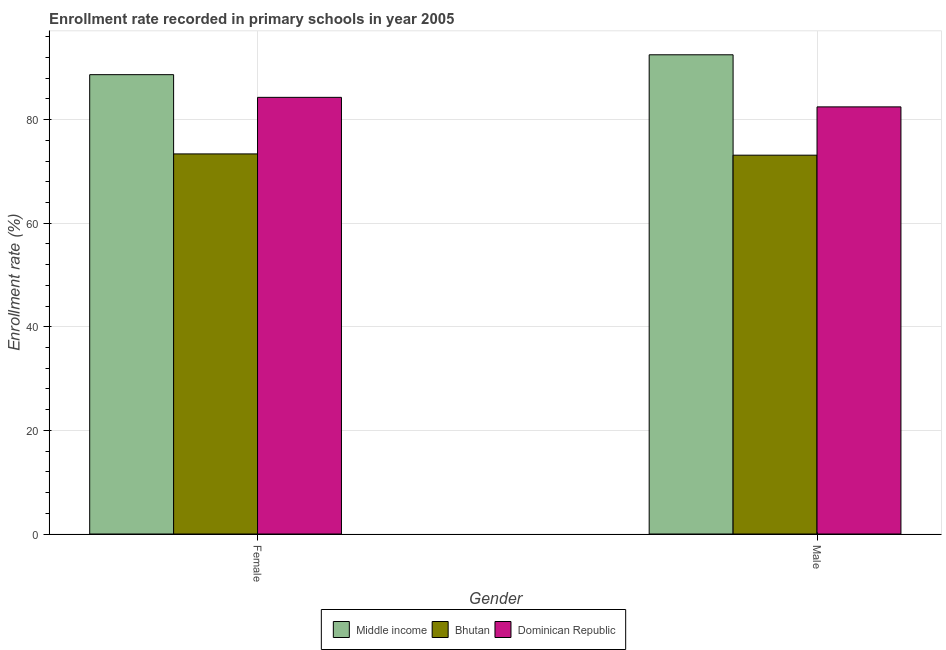How many groups of bars are there?
Your answer should be very brief. 2. Are the number of bars on each tick of the X-axis equal?
Your answer should be compact. Yes. How many bars are there on the 2nd tick from the left?
Your answer should be very brief. 3. What is the enrollment rate of male students in Middle income?
Offer a very short reply. 92.51. Across all countries, what is the maximum enrollment rate of male students?
Make the answer very short. 92.51. Across all countries, what is the minimum enrollment rate of female students?
Make the answer very short. 73.38. In which country was the enrollment rate of male students minimum?
Offer a very short reply. Bhutan. What is the total enrollment rate of female students in the graph?
Your answer should be compact. 246.35. What is the difference between the enrollment rate of male students in Middle income and that in Bhutan?
Ensure brevity in your answer.  19.38. What is the difference between the enrollment rate of male students in Bhutan and the enrollment rate of female students in Dominican Republic?
Offer a terse response. -11.16. What is the average enrollment rate of female students per country?
Provide a succinct answer. 82.12. What is the difference between the enrollment rate of female students and enrollment rate of male students in Dominican Republic?
Provide a succinct answer. 1.84. In how many countries, is the enrollment rate of female students greater than 24 %?
Your answer should be very brief. 3. What is the ratio of the enrollment rate of female students in Middle income to that in Dominican Republic?
Keep it short and to the point. 1.05. Is the enrollment rate of female students in Middle income less than that in Dominican Republic?
Ensure brevity in your answer.  No. In how many countries, is the enrollment rate of male students greater than the average enrollment rate of male students taken over all countries?
Your answer should be compact. 1. What does the 2nd bar from the left in Male represents?
Offer a very short reply. Bhutan. How many countries are there in the graph?
Your answer should be very brief. 3. What is the difference between two consecutive major ticks on the Y-axis?
Your answer should be very brief. 20. Are the values on the major ticks of Y-axis written in scientific E-notation?
Ensure brevity in your answer.  No. Does the graph contain any zero values?
Provide a succinct answer. No. Does the graph contain grids?
Keep it short and to the point. Yes. What is the title of the graph?
Keep it short and to the point. Enrollment rate recorded in primary schools in year 2005. What is the label or title of the X-axis?
Make the answer very short. Gender. What is the label or title of the Y-axis?
Make the answer very short. Enrollment rate (%). What is the Enrollment rate (%) of Middle income in Female?
Make the answer very short. 88.68. What is the Enrollment rate (%) in Bhutan in Female?
Your answer should be very brief. 73.38. What is the Enrollment rate (%) in Dominican Republic in Female?
Keep it short and to the point. 84.3. What is the Enrollment rate (%) in Middle income in Male?
Your answer should be very brief. 92.51. What is the Enrollment rate (%) in Bhutan in Male?
Your response must be concise. 73.13. What is the Enrollment rate (%) of Dominican Republic in Male?
Your answer should be compact. 82.46. Across all Gender, what is the maximum Enrollment rate (%) in Middle income?
Your response must be concise. 92.51. Across all Gender, what is the maximum Enrollment rate (%) of Bhutan?
Your answer should be very brief. 73.38. Across all Gender, what is the maximum Enrollment rate (%) in Dominican Republic?
Provide a succinct answer. 84.3. Across all Gender, what is the minimum Enrollment rate (%) of Middle income?
Offer a terse response. 88.68. Across all Gender, what is the minimum Enrollment rate (%) in Bhutan?
Your answer should be very brief. 73.13. Across all Gender, what is the minimum Enrollment rate (%) in Dominican Republic?
Your response must be concise. 82.46. What is the total Enrollment rate (%) of Middle income in the graph?
Your answer should be very brief. 181.19. What is the total Enrollment rate (%) in Bhutan in the graph?
Your answer should be compact. 146.51. What is the total Enrollment rate (%) of Dominican Republic in the graph?
Your response must be concise. 166.75. What is the difference between the Enrollment rate (%) of Middle income in Female and that in Male?
Offer a terse response. -3.84. What is the difference between the Enrollment rate (%) of Bhutan in Female and that in Male?
Make the answer very short. 0.24. What is the difference between the Enrollment rate (%) of Dominican Republic in Female and that in Male?
Make the answer very short. 1.84. What is the difference between the Enrollment rate (%) of Middle income in Female and the Enrollment rate (%) of Bhutan in Male?
Provide a short and direct response. 15.54. What is the difference between the Enrollment rate (%) of Middle income in Female and the Enrollment rate (%) of Dominican Republic in Male?
Give a very brief answer. 6.22. What is the difference between the Enrollment rate (%) of Bhutan in Female and the Enrollment rate (%) of Dominican Republic in Male?
Your answer should be very brief. -9.08. What is the average Enrollment rate (%) in Middle income per Gender?
Your answer should be very brief. 90.59. What is the average Enrollment rate (%) in Bhutan per Gender?
Your answer should be compact. 73.26. What is the average Enrollment rate (%) in Dominican Republic per Gender?
Ensure brevity in your answer.  83.38. What is the difference between the Enrollment rate (%) of Middle income and Enrollment rate (%) of Bhutan in Female?
Keep it short and to the point. 15.3. What is the difference between the Enrollment rate (%) of Middle income and Enrollment rate (%) of Dominican Republic in Female?
Keep it short and to the point. 4.38. What is the difference between the Enrollment rate (%) of Bhutan and Enrollment rate (%) of Dominican Republic in Female?
Offer a very short reply. -10.92. What is the difference between the Enrollment rate (%) in Middle income and Enrollment rate (%) in Bhutan in Male?
Offer a terse response. 19.38. What is the difference between the Enrollment rate (%) of Middle income and Enrollment rate (%) of Dominican Republic in Male?
Your response must be concise. 10.06. What is the difference between the Enrollment rate (%) in Bhutan and Enrollment rate (%) in Dominican Republic in Male?
Offer a very short reply. -9.32. What is the ratio of the Enrollment rate (%) of Middle income in Female to that in Male?
Your answer should be compact. 0.96. What is the ratio of the Enrollment rate (%) of Dominican Republic in Female to that in Male?
Give a very brief answer. 1.02. What is the difference between the highest and the second highest Enrollment rate (%) in Middle income?
Offer a very short reply. 3.84. What is the difference between the highest and the second highest Enrollment rate (%) in Bhutan?
Make the answer very short. 0.24. What is the difference between the highest and the second highest Enrollment rate (%) of Dominican Republic?
Your answer should be compact. 1.84. What is the difference between the highest and the lowest Enrollment rate (%) of Middle income?
Keep it short and to the point. 3.84. What is the difference between the highest and the lowest Enrollment rate (%) in Bhutan?
Offer a very short reply. 0.24. What is the difference between the highest and the lowest Enrollment rate (%) of Dominican Republic?
Offer a very short reply. 1.84. 